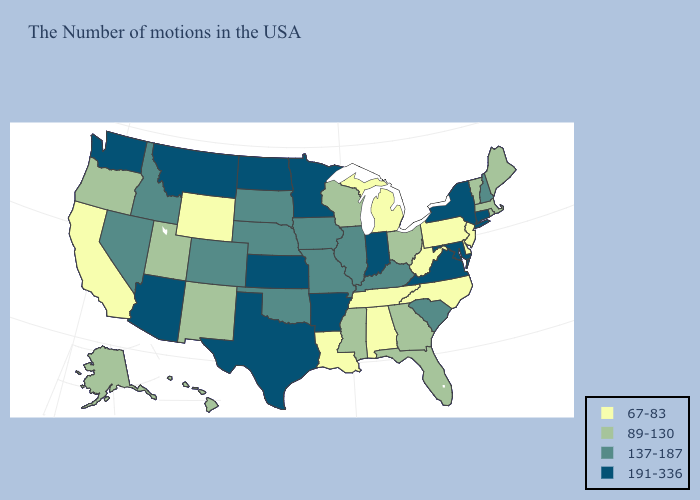What is the lowest value in the USA?
Short answer required. 67-83. Which states have the highest value in the USA?
Be succinct. Connecticut, New York, Maryland, Virginia, Indiana, Arkansas, Minnesota, Kansas, Texas, North Dakota, Montana, Arizona, Washington. Among the states that border Iowa , does Wisconsin have the lowest value?
Write a very short answer. Yes. Name the states that have a value in the range 137-187?
Write a very short answer. New Hampshire, South Carolina, Kentucky, Illinois, Missouri, Iowa, Nebraska, Oklahoma, South Dakota, Colorado, Idaho, Nevada. Does Montana have the highest value in the USA?
Answer briefly. Yes. Does Delaware have a higher value than Arizona?
Give a very brief answer. No. What is the value of Virginia?
Concise answer only. 191-336. Among the states that border Illinois , does Iowa have the highest value?
Short answer required. No. Does Tennessee have a higher value than Illinois?
Keep it brief. No. Which states have the highest value in the USA?
Answer briefly. Connecticut, New York, Maryland, Virginia, Indiana, Arkansas, Minnesota, Kansas, Texas, North Dakota, Montana, Arizona, Washington. What is the highest value in the South ?
Be succinct. 191-336. Does New York have the lowest value in the Northeast?
Short answer required. No. Does California have the lowest value in the West?
Give a very brief answer. Yes. What is the value of Florida?
Quick response, please. 89-130. What is the highest value in the West ?
Give a very brief answer. 191-336. 